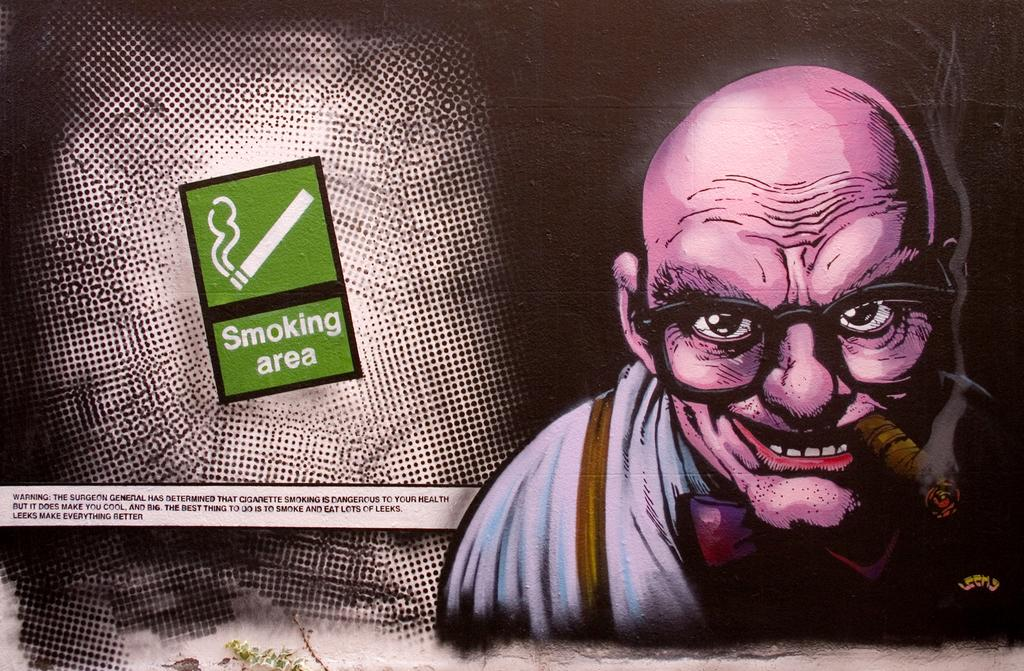What type of image is depicted in the picture? There is an animated picture of a person in the image. What is the person wearing in the image? The person is wearing clothes and spectacles. What is the person doing with an object in the image? The person is holding an object in his mouth. What additional elements are present in the image? There is text and a symbol of a cigarette in the image. How does the person's growth change throughout the image? The image does not depict any growth or change in the person's size; it is a static image. What type of thrill can be experienced by the person in the image? There is no indication of any thrill or excitement being experienced by the person in the image, as they are simply holding an object in their mouth. 